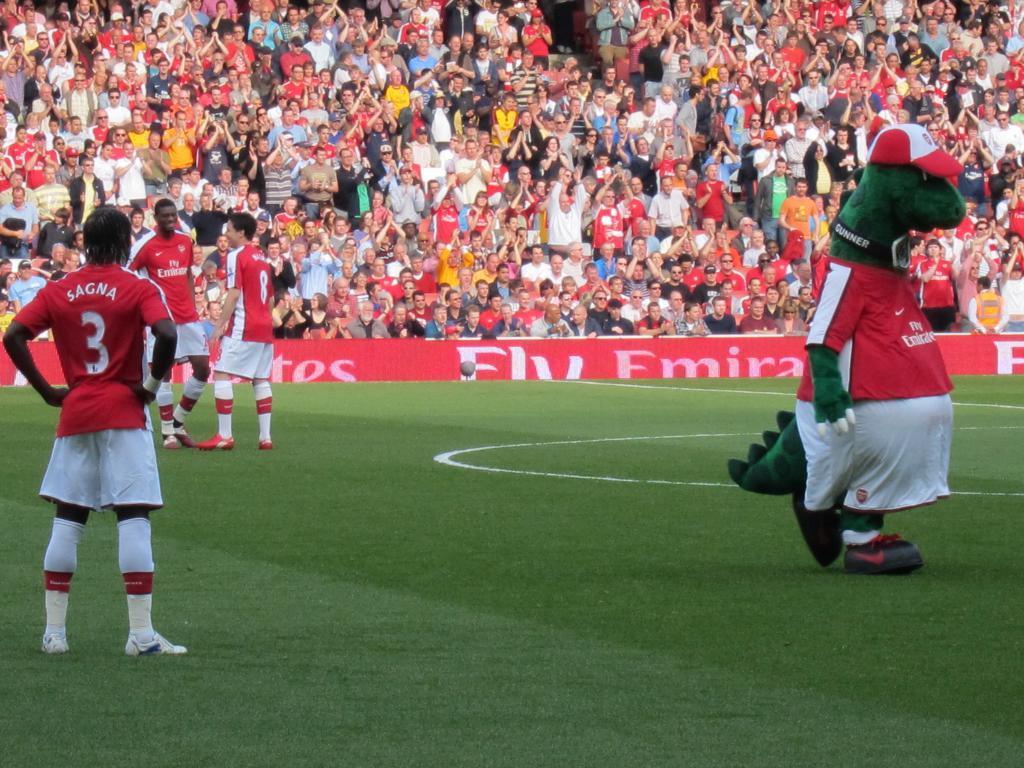Please provide a concise description of this image. This picture describes about group of people, few people are seated and few are standing, and also we can find few hoardings and grass. 